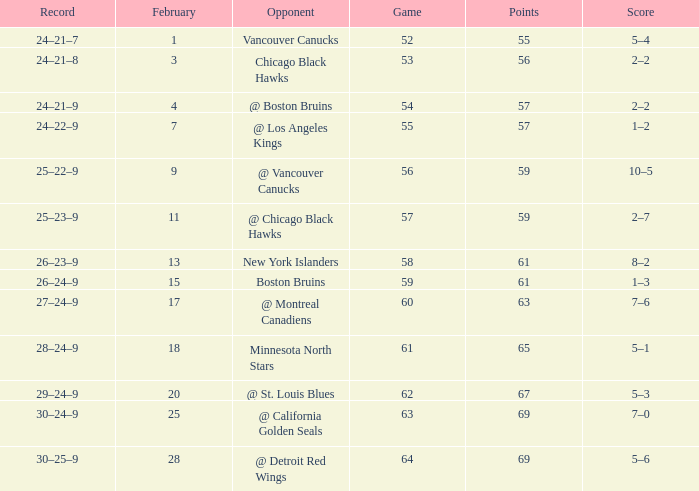Which opponent has a game larger than 61, february smaller than 28, and fewer points than 69? @ St. Louis Blues. 